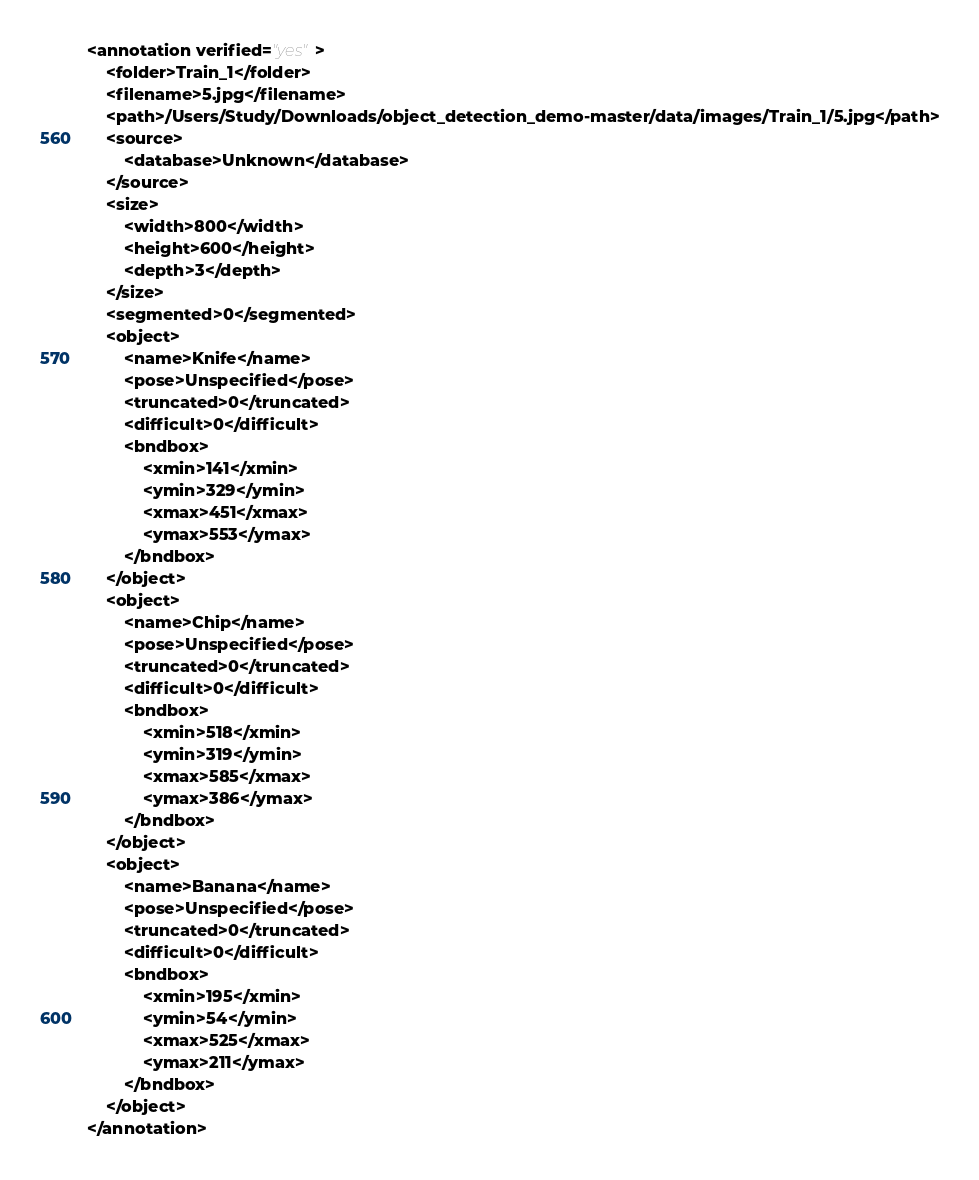Convert code to text. <code><loc_0><loc_0><loc_500><loc_500><_XML_><annotation verified="yes">
	<folder>Train_1</folder>
	<filename>5.jpg</filename>
	<path>/Users/Study/Downloads/object_detection_demo-master/data/images/Train_1/5.jpg</path>
	<source>
		<database>Unknown</database>
	</source>
	<size>
		<width>800</width>
		<height>600</height>
		<depth>3</depth>
	</size>
	<segmented>0</segmented>
	<object>
		<name>Knife</name>
		<pose>Unspecified</pose>
		<truncated>0</truncated>
		<difficult>0</difficult>
		<bndbox>
			<xmin>141</xmin>
			<ymin>329</ymin>
			<xmax>451</xmax>
			<ymax>553</ymax>
		</bndbox>
	</object>
	<object>
		<name>Chip</name>
		<pose>Unspecified</pose>
		<truncated>0</truncated>
		<difficult>0</difficult>
		<bndbox>
			<xmin>518</xmin>
			<ymin>319</ymin>
			<xmax>585</xmax>
			<ymax>386</ymax>
		</bndbox>
	</object>
	<object>
		<name>Banana</name>
		<pose>Unspecified</pose>
		<truncated>0</truncated>
		<difficult>0</difficult>
		<bndbox>
			<xmin>195</xmin>
			<ymin>54</ymin>
			<xmax>525</xmax>
			<ymax>211</ymax>
		</bndbox>
	</object>
</annotation>
</code> 